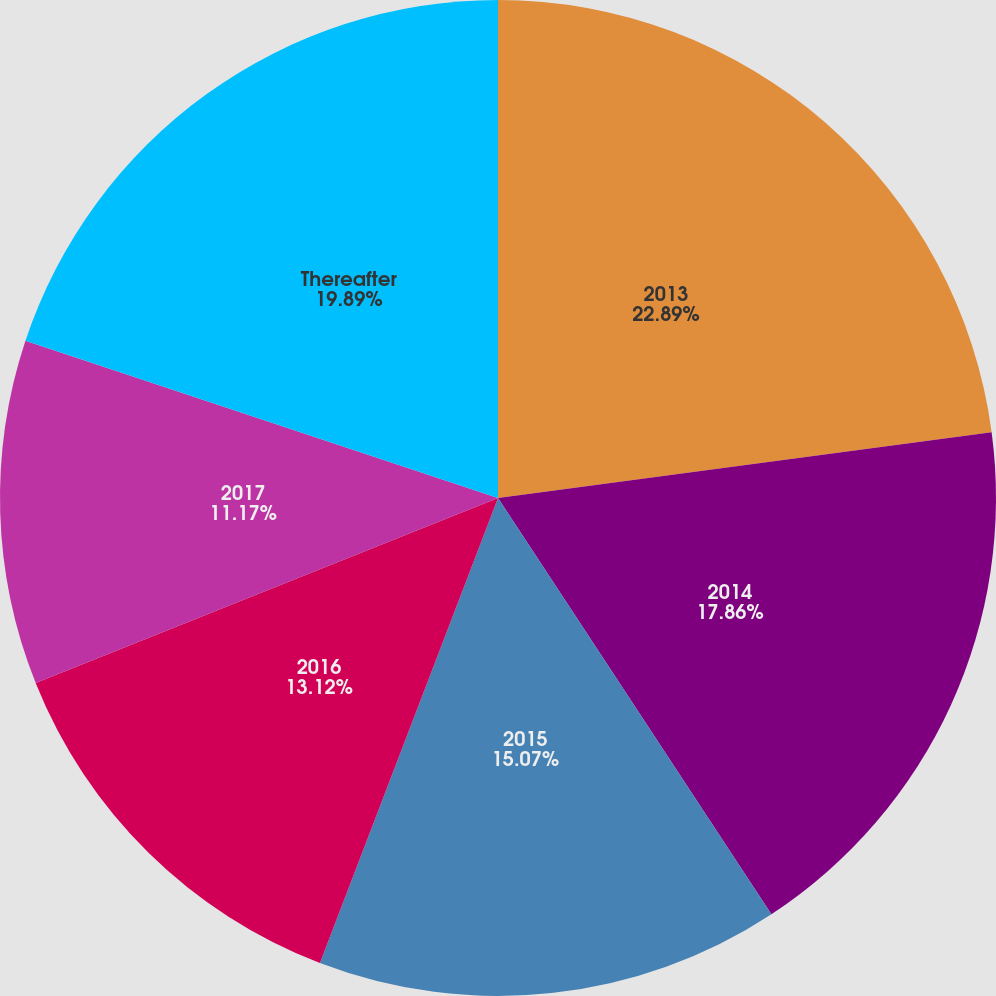<chart> <loc_0><loc_0><loc_500><loc_500><pie_chart><fcel>2013<fcel>2014<fcel>2015<fcel>2016<fcel>2017<fcel>Thereafter<nl><fcel>22.89%<fcel>17.86%<fcel>15.07%<fcel>13.12%<fcel>11.17%<fcel>19.89%<nl></chart> 